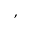Convert formula to latex. <formula><loc_0><loc_0><loc_500><loc_500>,</formula> 